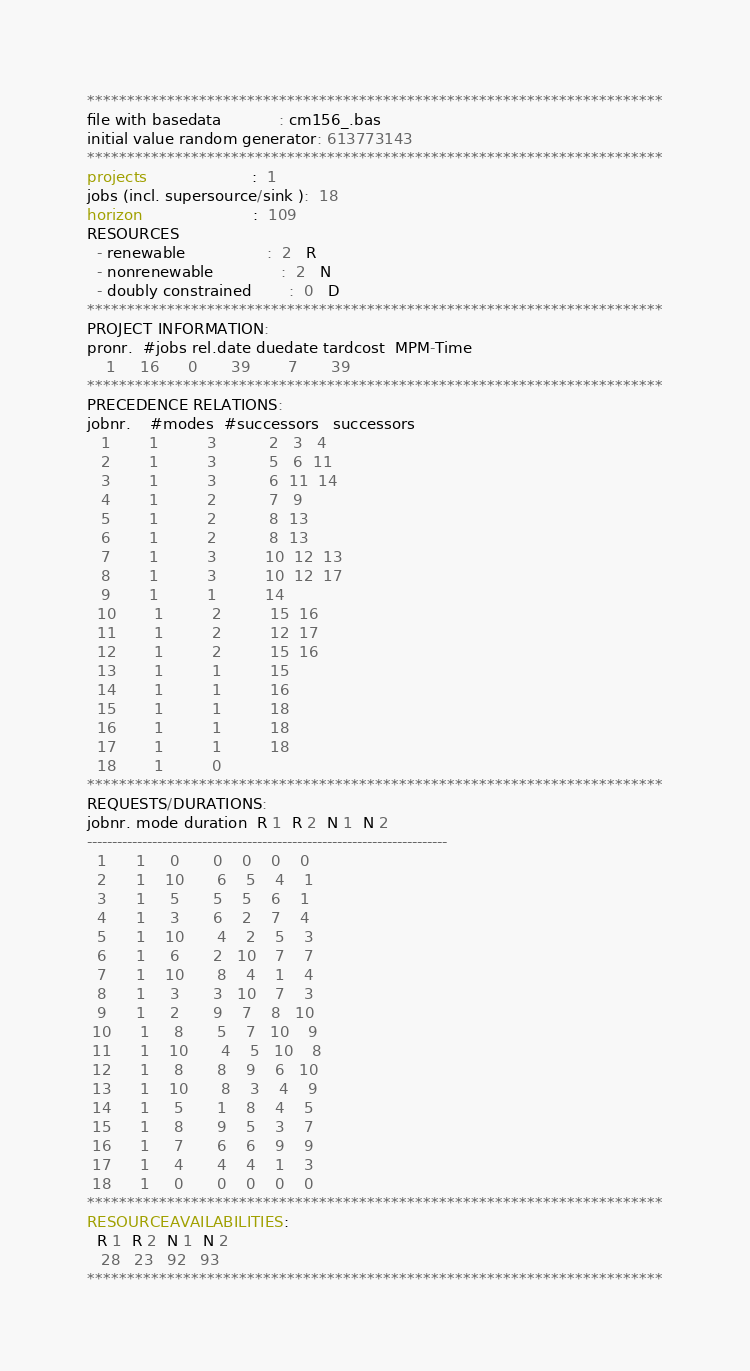<code> <loc_0><loc_0><loc_500><loc_500><_ObjectiveC_>************************************************************************
file with basedata            : cm156_.bas
initial value random generator: 613773143
************************************************************************
projects                      :  1
jobs (incl. supersource/sink ):  18
horizon                       :  109
RESOURCES
  - renewable                 :  2   R
  - nonrenewable              :  2   N
  - doubly constrained        :  0   D
************************************************************************
PROJECT INFORMATION:
pronr.  #jobs rel.date duedate tardcost  MPM-Time
    1     16      0       39        7       39
************************************************************************
PRECEDENCE RELATIONS:
jobnr.    #modes  #successors   successors
   1        1          3           2   3   4
   2        1          3           5   6  11
   3        1          3           6  11  14
   4        1          2           7   9
   5        1          2           8  13
   6        1          2           8  13
   7        1          3          10  12  13
   8        1          3          10  12  17
   9        1          1          14
  10        1          2          15  16
  11        1          2          12  17
  12        1          2          15  16
  13        1          1          15
  14        1          1          16
  15        1          1          18
  16        1          1          18
  17        1          1          18
  18        1          0        
************************************************************************
REQUESTS/DURATIONS:
jobnr. mode duration  R 1  R 2  N 1  N 2
------------------------------------------------------------------------
  1      1     0       0    0    0    0
  2      1    10       6    5    4    1
  3      1     5       5    5    6    1
  4      1     3       6    2    7    4
  5      1    10       4    2    5    3
  6      1     6       2   10    7    7
  7      1    10       8    4    1    4
  8      1     3       3   10    7    3
  9      1     2       9    7    8   10
 10      1     8       5    7   10    9
 11      1    10       4    5   10    8
 12      1     8       8    9    6   10
 13      1    10       8    3    4    9
 14      1     5       1    8    4    5
 15      1     8       9    5    3    7
 16      1     7       6    6    9    9
 17      1     4       4    4    1    3
 18      1     0       0    0    0    0
************************************************************************
RESOURCEAVAILABILITIES:
  R 1  R 2  N 1  N 2
   28   23   92   93
************************************************************************
</code> 